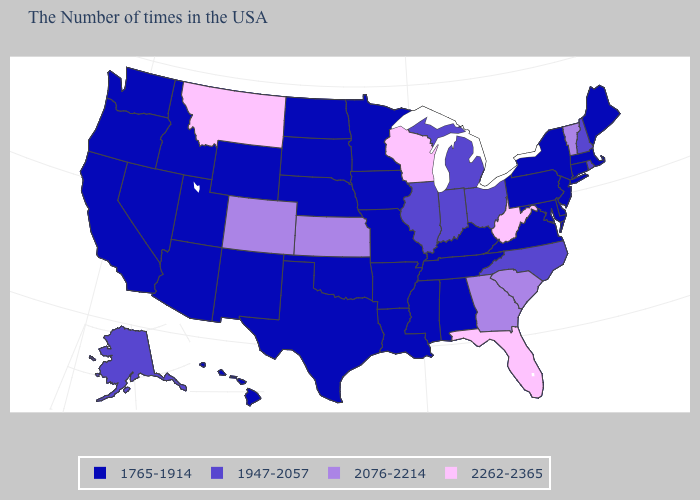What is the value of Maine?
Short answer required. 1765-1914. Name the states that have a value in the range 1947-2057?
Give a very brief answer. Rhode Island, New Hampshire, North Carolina, Ohio, Michigan, Indiana, Illinois, Alaska. What is the value of North Carolina?
Give a very brief answer. 1947-2057. Does Alabama have the lowest value in the USA?
Answer briefly. Yes. Name the states that have a value in the range 2076-2214?
Answer briefly. Vermont, South Carolina, Georgia, Kansas, Colorado. Which states have the highest value in the USA?
Write a very short answer. West Virginia, Florida, Wisconsin, Montana. Among the states that border Vermont , which have the lowest value?
Quick response, please. Massachusetts, New York. What is the lowest value in the USA?
Answer briefly. 1765-1914. Among the states that border Indiana , which have the highest value?
Quick response, please. Ohio, Michigan, Illinois. What is the value of Wyoming?
Give a very brief answer. 1765-1914. What is the value of Kentucky?
Short answer required. 1765-1914. Name the states that have a value in the range 2076-2214?
Write a very short answer. Vermont, South Carolina, Georgia, Kansas, Colorado. Name the states that have a value in the range 2076-2214?
Concise answer only. Vermont, South Carolina, Georgia, Kansas, Colorado. Which states have the lowest value in the South?
Concise answer only. Delaware, Maryland, Virginia, Kentucky, Alabama, Tennessee, Mississippi, Louisiana, Arkansas, Oklahoma, Texas. 